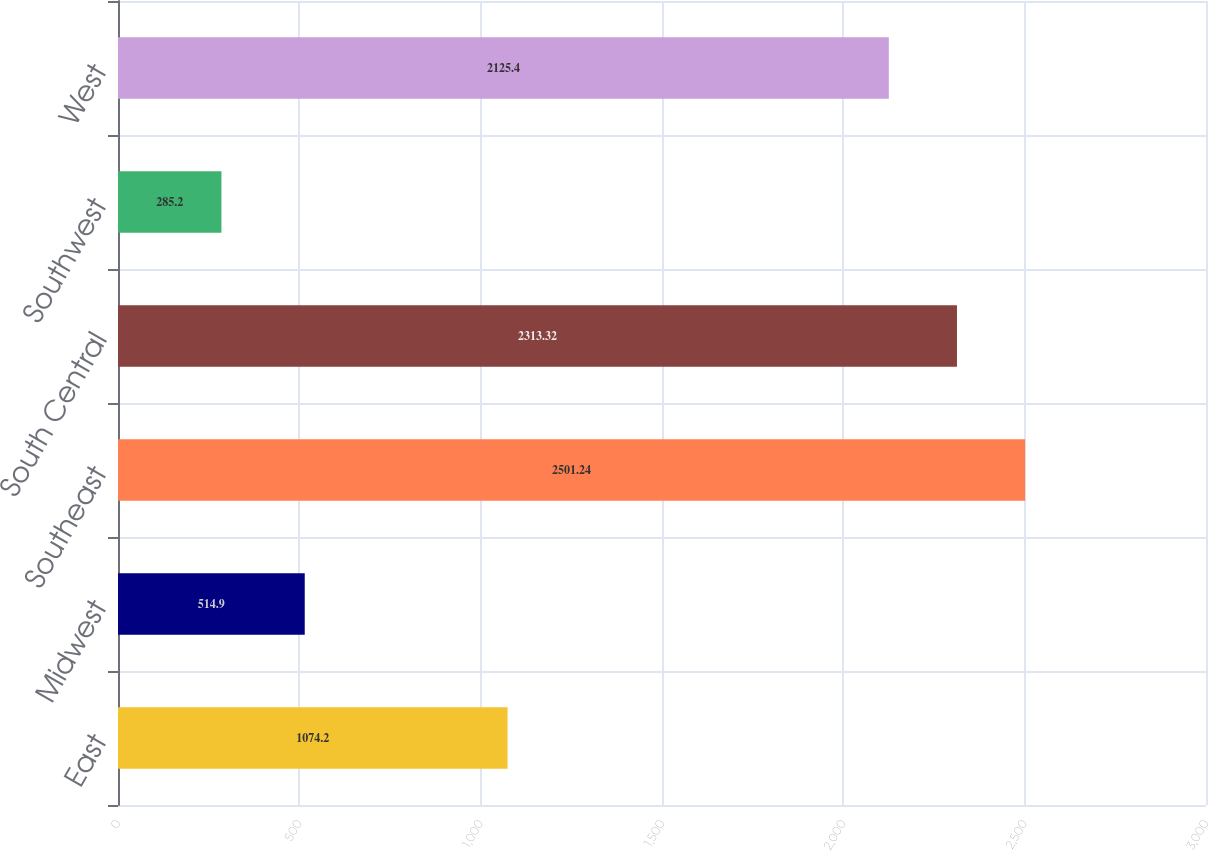Convert chart. <chart><loc_0><loc_0><loc_500><loc_500><bar_chart><fcel>East<fcel>Midwest<fcel>Southeast<fcel>South Central<fcel>Southwest<fcel>West<nl><fcel>1074.2<fcel>514.9<fcel>2501.24<fcel>2313.32<fcel>285.2<fcel>2125.4<nl></chart> 